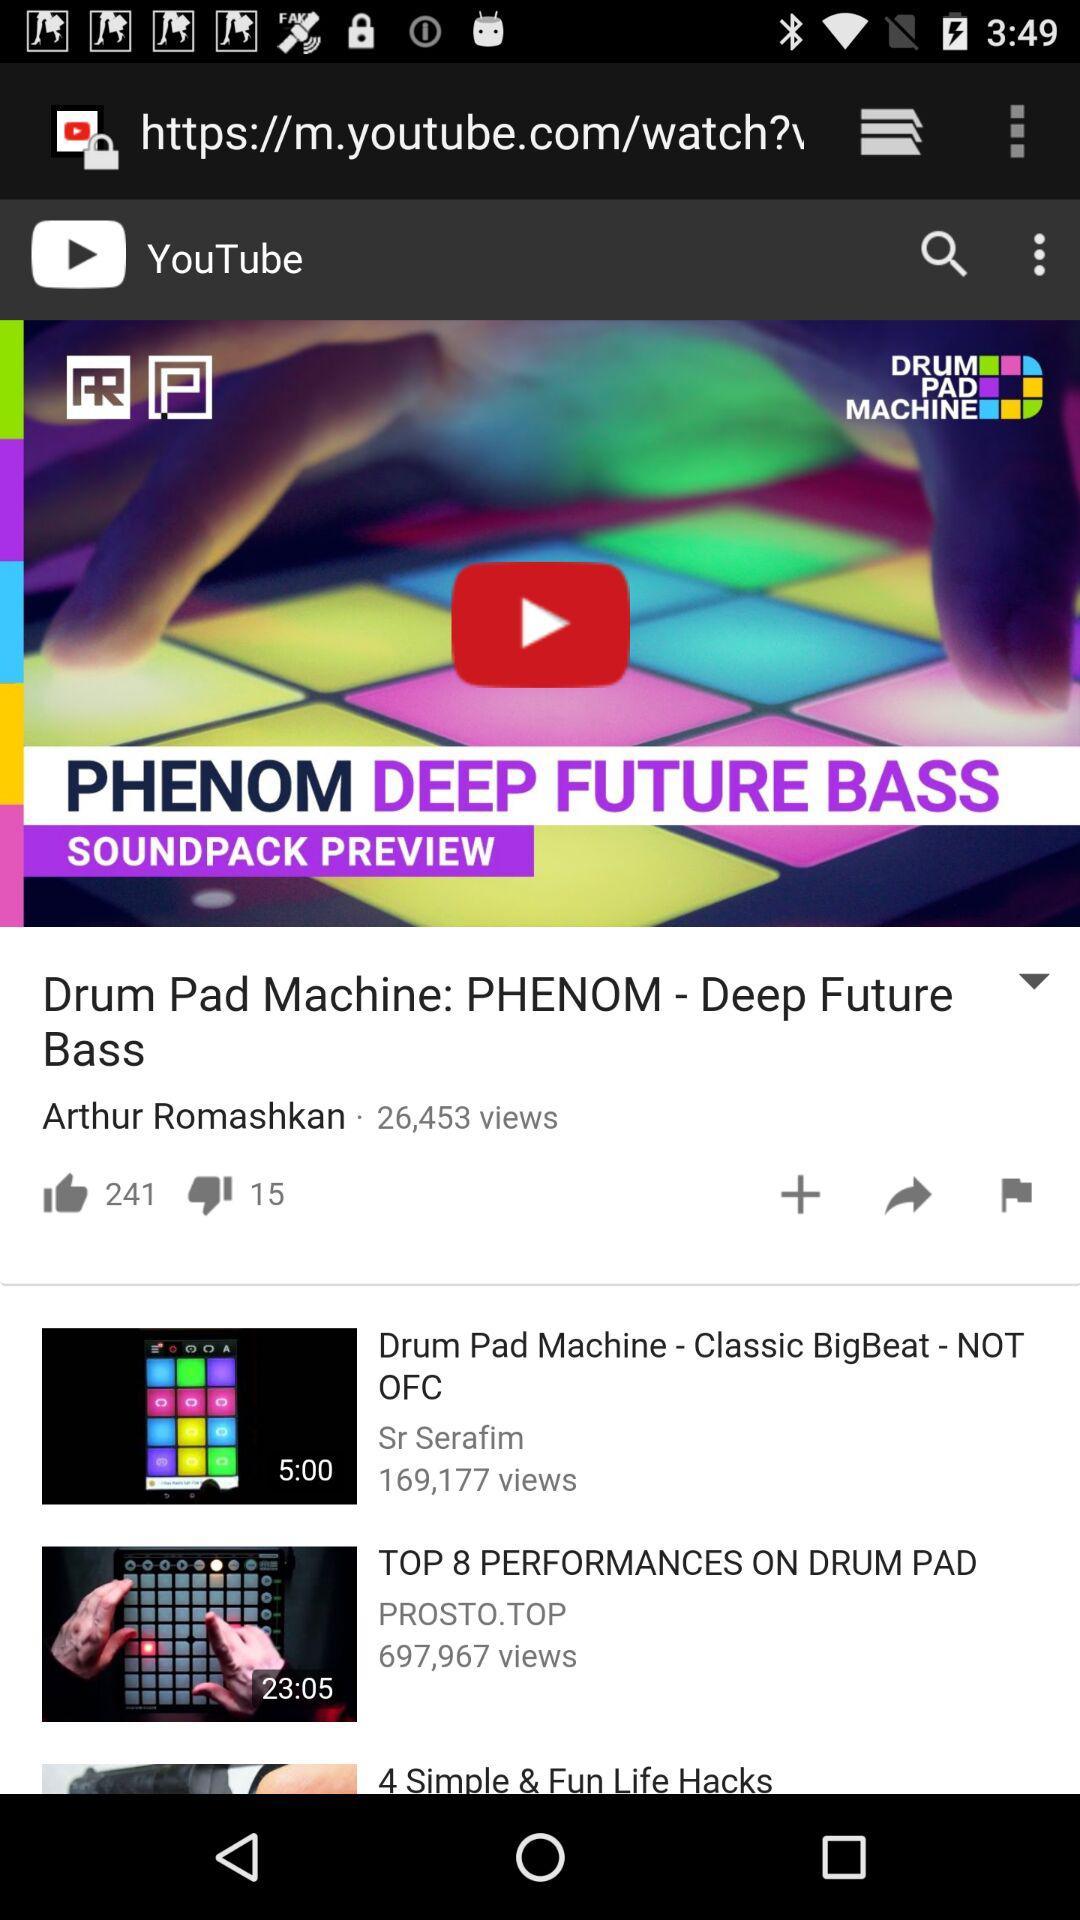How many more thumbs up than down does the video have?
Answer the question using a single word or phrase. 226 